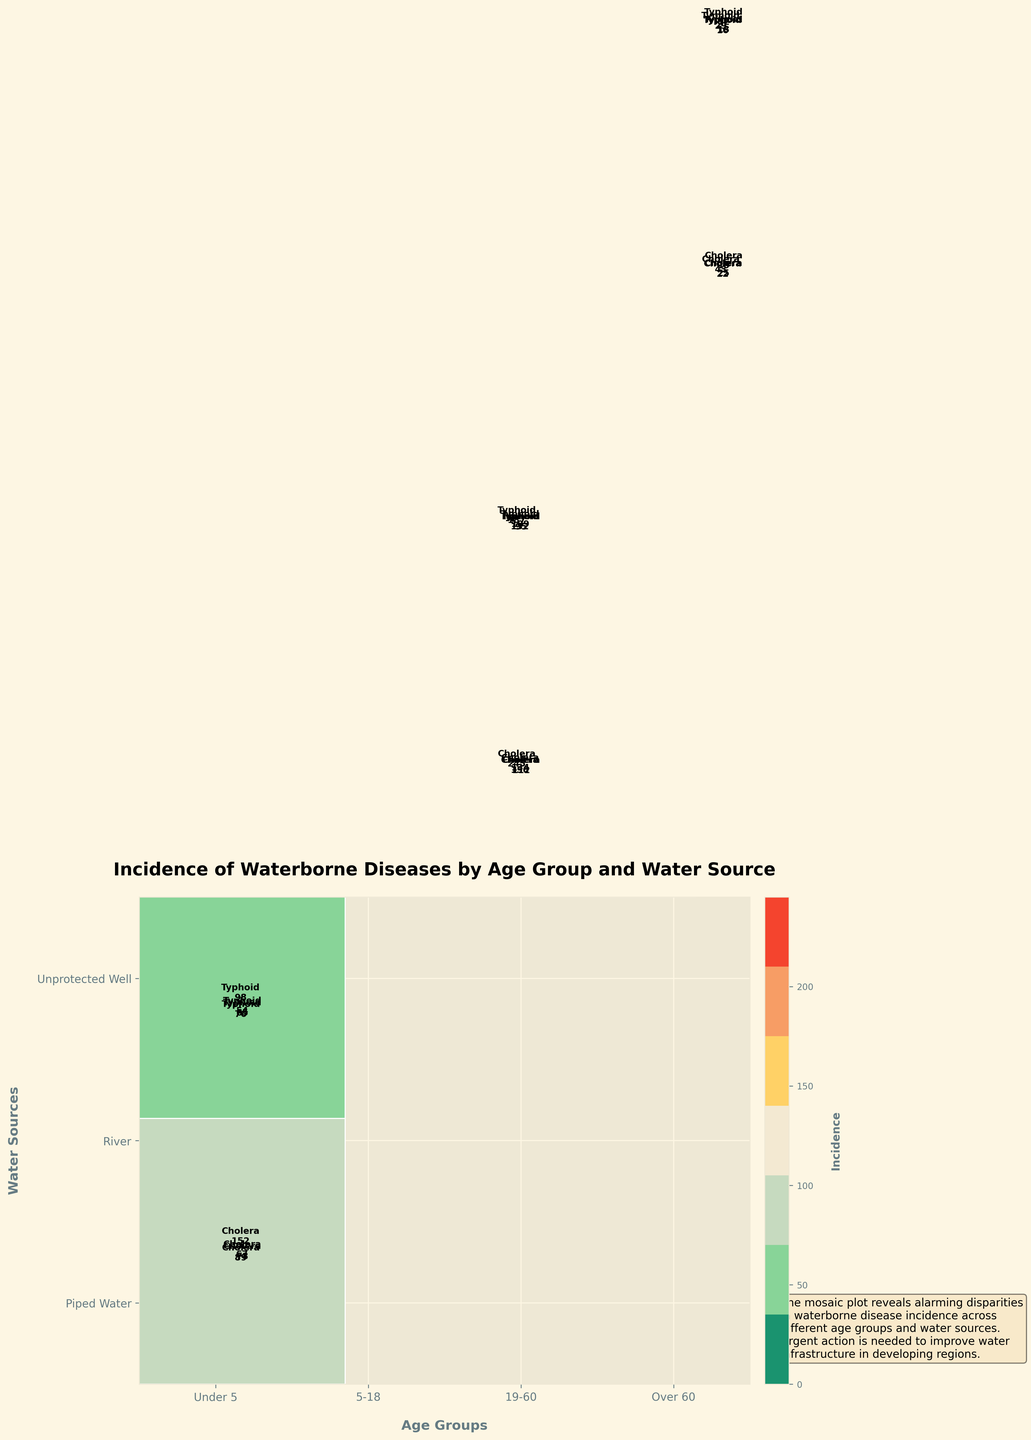What are the age groups displayed in the plot? The age groups can be identified by looking at the x-axis which shows the categories. The labels on the x-axis represent the age groups.
Answer: Under 5, 5-18, 19-60, Over 60 Which water source shows the highest incidence of cholera for the Under 5 age group? Look at the section of the mosaic plot corresponding to the Under 5 age group and compare the height of the rectangles for each water source that represents cholera. The tallest rectangle indicates the highest incidence.
Answer: River For the 5-18 age group, how does the incidence of typhoid compare between unprotected wells and piped water? In the 5-18 age group section, identify the rectangles for typhoid corresponding to unprotected wells and piped water. Compare their heights to determine which is higher.
Answer: Unprotected wells have higher incidence What is the total incidence of waterborne diseases for the Over 60 age group? Sum the incidence values for all water sources and diseases within the Over 60 age group section of the mosaic plot.
Answer: 424 Among the age groups, which one has the lowest incidence of cholera from piped water? Examine the rectangles representing cholera incidences from piped water in each age group and identify the one with the smallest height.
Answer: 19-60 What color is used to represent the highest incidence of diseases in the plot? Refer to the color bar on the plot that indicates incidences. The color corresponding to the maximum value will be the one representing the highest incidence.
Answer: Dark red (conversion from the color code used) Which disease has a higher overall incidence in rivers for the 19-60 age group, cholera or typhoid? Look at the section corresponding to rivers in the 19-60 age group and compare the heights of the rectangles for cholera and typhoid. The taller rectangle indicates the higher incidence.
Answer: Cholera Is the incidence of waterborne diseases in rivers generally higher or lower than in piped water across all age groups? Compare the height of the rectangles for rivers and piped water in each age group, and then determine if the former is generally higher or lower.
Answer: Higher Which age group has the largest disparity between cholera incidence from unprotected wells and piped water? Calculate the difference in heights between the rectangles representing cholera incidences from unprotected wells and piped water for each age group. Identify the age group with the largest difference.
Answer: Under 5 